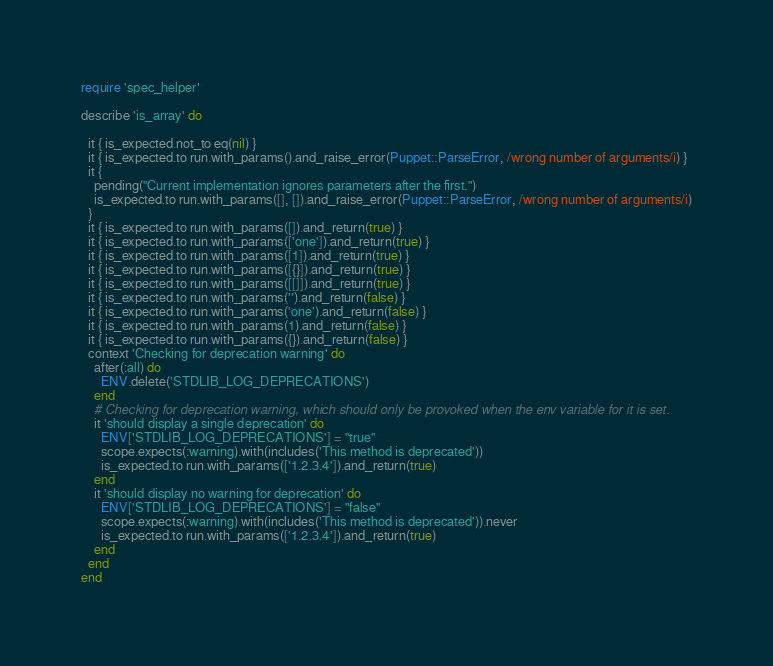<code> <loc_0><loc_0><loc_500><loc_500><_Ruby_>require 'spec_helper'

describe 'is_array' do
  
  it { is_expected.not_to eq(nil) }
  it { is_expected.to run.with_params().and_raise_error(Puppet::ParseError, /wrong number of arguments/i) }
  it {
    pending("Current implementation ignores parameters after the first.")
    is_expected.to run.with_params([], []).and_raise_error(Puppet::ParseError, /wrong number of arguments/i)
  }
  it { is_expected.to run.with_params([]).and_return(true) }
  it { is_expected.to run.with_params(['one']).and_return(true) }
  it { is_expected.to run.with_params([1]).and_return(true) }
  it { is_expected.to run.with_params([{}]).and_return(true) }
  it { is_expected.to run.with_params([[]]).and_return(true) }
  it { is_expected.to run.with_params('').and_return(false) }
  it { is_expected.to run.with_params('one').and_return(false) }
  it { is_expected.to run.with_params(1).and_return(false) }
  it { is_expected.to run.with_params({}).and_return(false) }
  context 'Checking for deprecation warning' do
    after(:all) do
      ENV.delete('STDLIB_LOG_DEPRECATIONS')
    end 
    # Checking for deprecation warning, which should only be provoked when the env variable for it is set.
    it 'should display a single deprecation' do
      ENV['STDLIB_LOG_DEPRECATIONS'] = "true"
      scope.expects(:warning).with(includes('This method is deprecated'))
      is_expected.to run.with_params(['1.2.3.4']).and_return(true)
    end
    it 'should display no warning for deprecation' do
      ENV['STDLIB_LOG_DEPRECATIONS'] = "false"
      scope.expects(:warning).with(includes('This method is deprecated')).never
      is_expected.to run.with_params(['1.2.3.4']).and_return(true)
    end
  end
end
</code> 